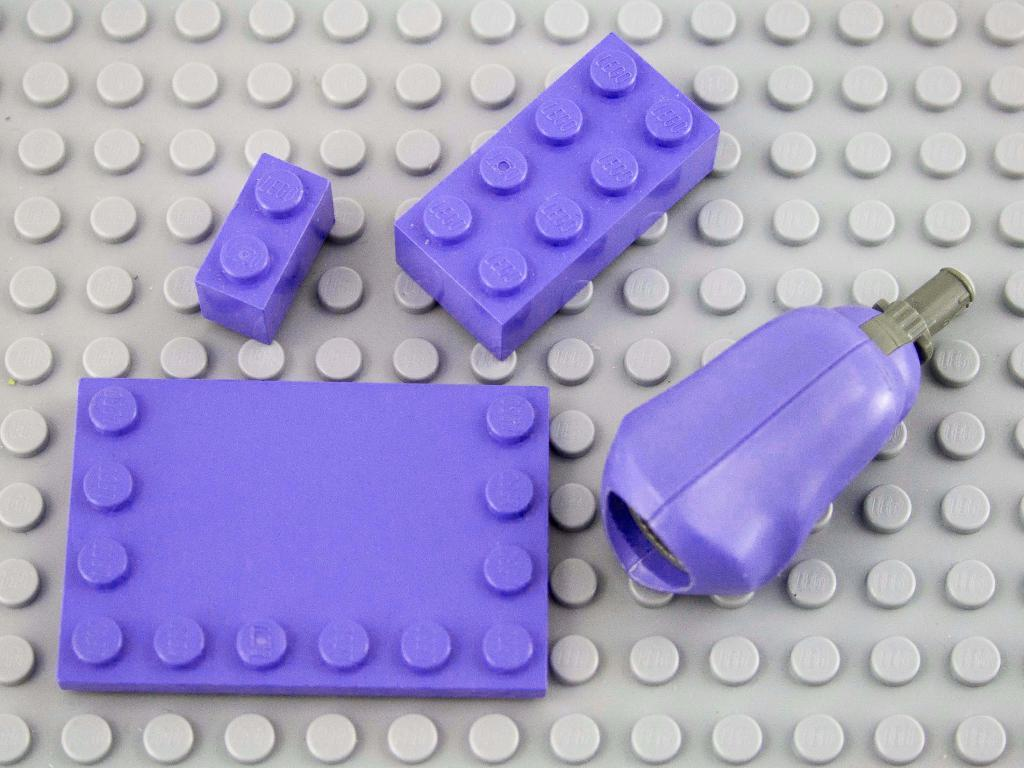What color are the objects in the image? The objects in the image are purple. What color is the object that the purple objects are on? The object that the purple objects are on is grey. How many members of the family are wearing masks in the image? There is no reference to a family or masks in the image, so this question cannot be answered. 